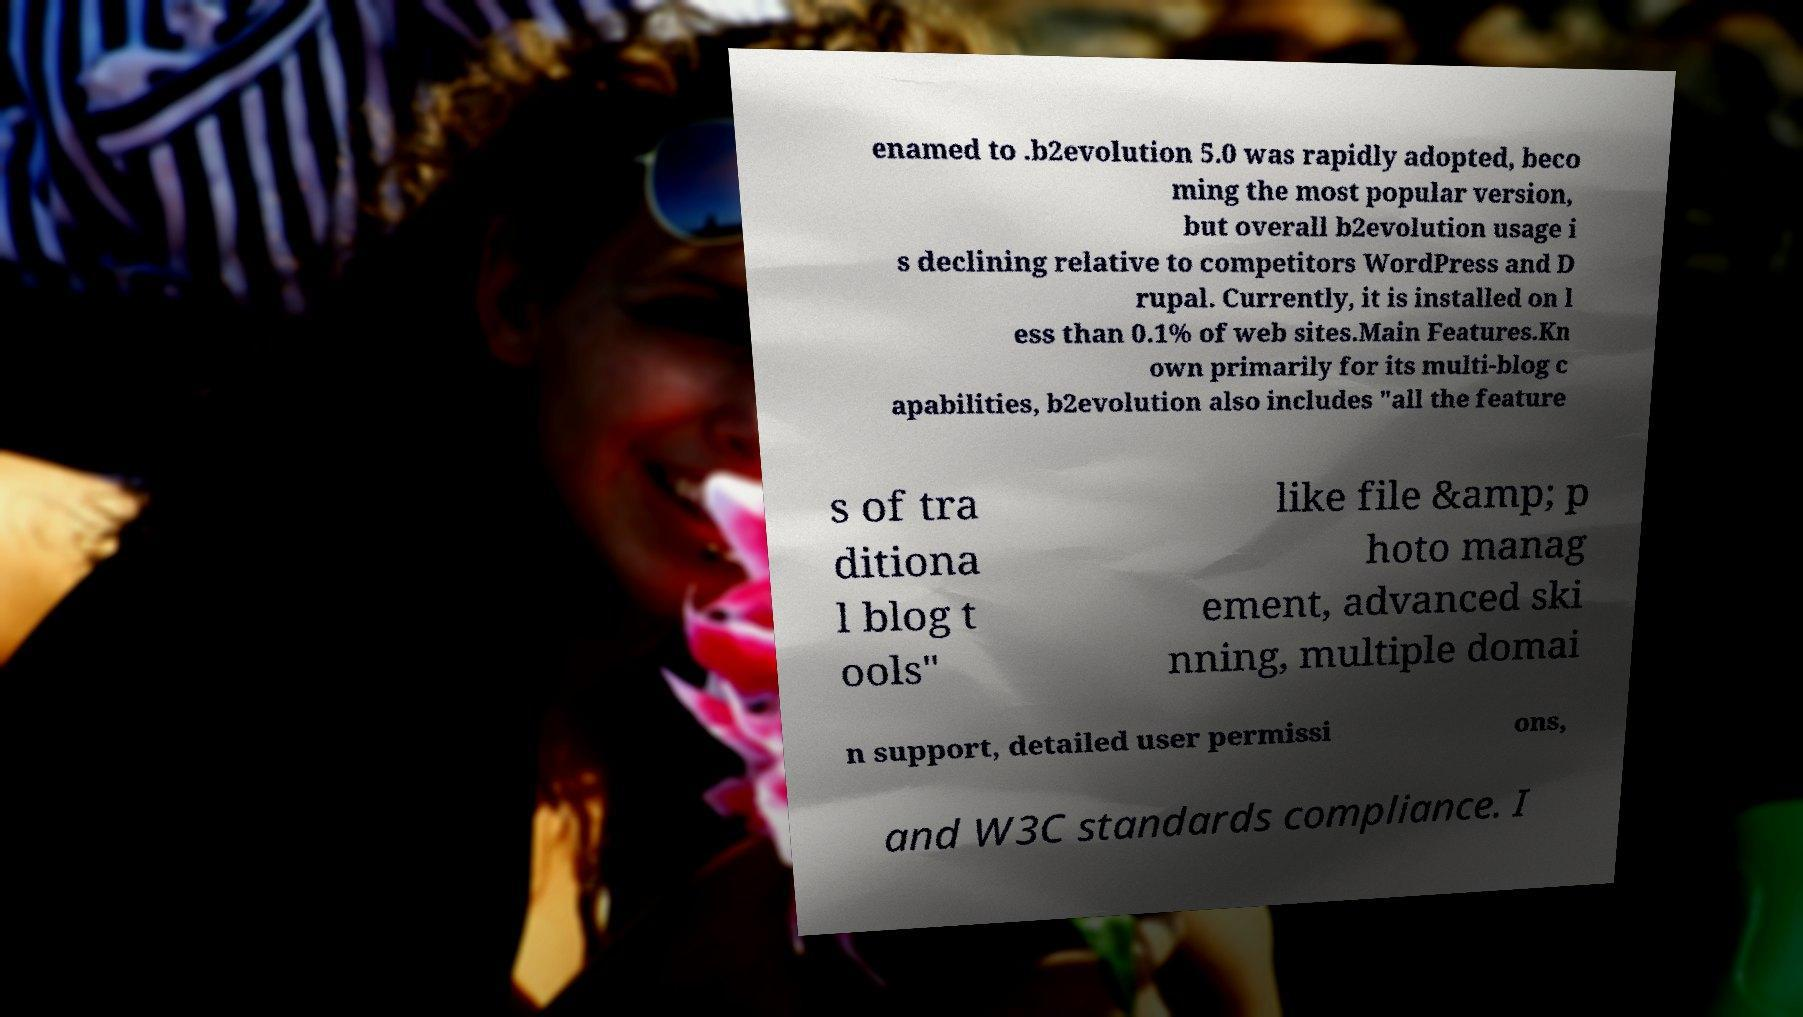Can you accurately transcribe the text from the provided image for me? enamed to .b2evolution 5.0 was rapidly adopted, beco ming the most popular version, but overall b2evolution usage i s declining relative to competitors WordPress and D rupal. Currently, it is installed on l ess than 0.1% of web sites.Main Features.Kn own primarily for its multi-blog c apabilities, b2evolution also includes "all the feature s of tra ditiona l blog t ools" like file &amp; p hoto manag ement, advanced ski nning, multiple domai n support, detailed user permissi ons, and W3C standards compliance. I 